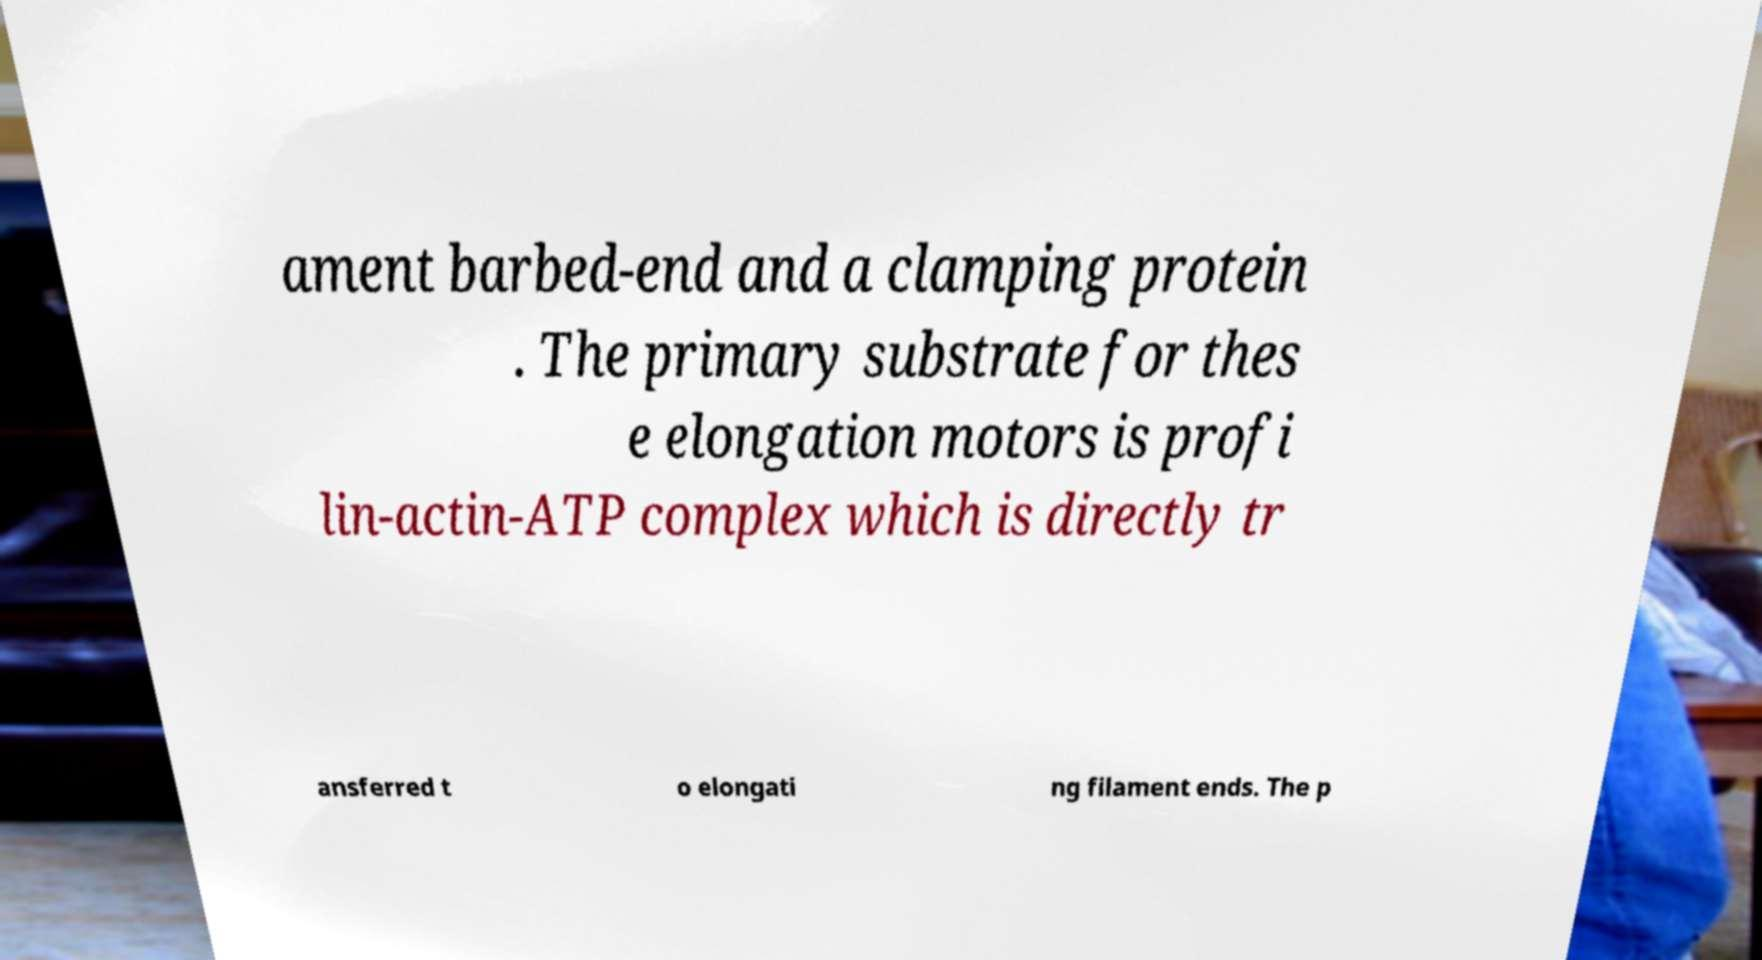For documentation purposes, I need the text within this image transcribed. Could you provide that? ament barbed-end and a clamping protein . The primary substrate for thes e elongation motors is profi lin-actin-ATP complex which is directly tr ansferred t o elongati ng filament ends. The p 